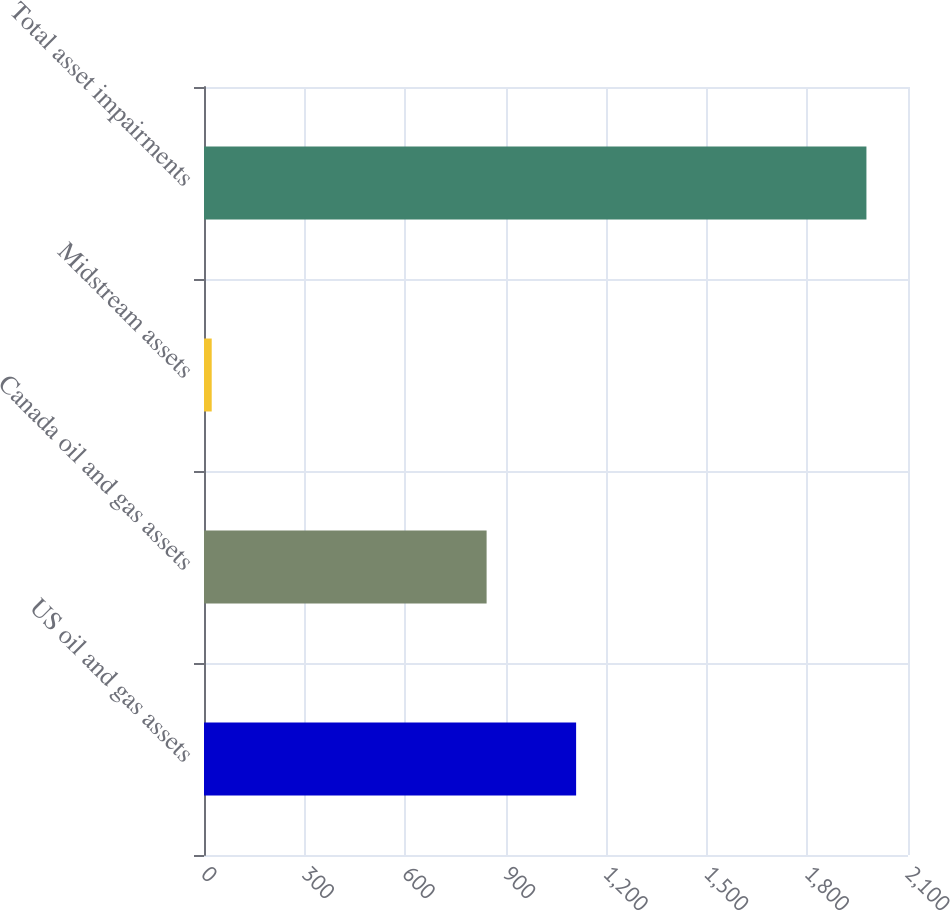Convert chart to OTSL. <chart><loc_0><loc_0><loc_500><loc_500><bar_chart><fcel>US oil and gas assets<fcel>Canada oil and gas assets<fcel>Midstream assets<fcel>Total asset impairments<nl><fcel>1110<fcel>843<fcel>23<fcel>1976<nl></chart> 